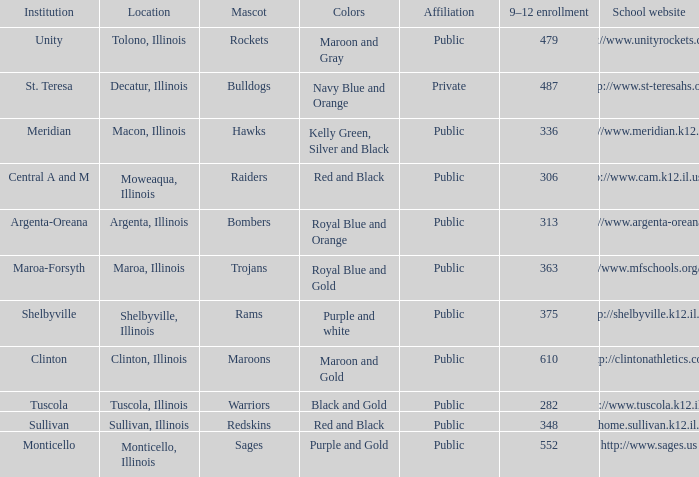How many different combinations of team colors are there in all the schools in Maroa, Illinois? 1.0. 